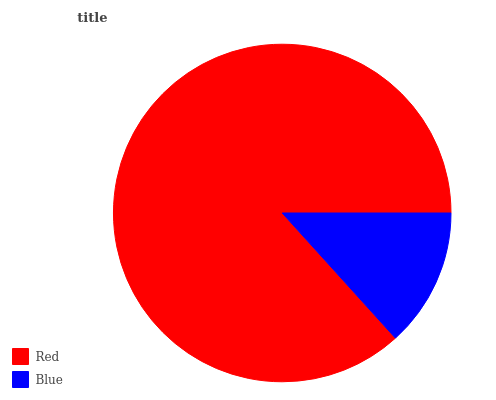Is Blue the minimum?
Answer yes or no. Yes. Is Red the maximum?
Answer yes or no. Yes. Is Blue the maximum?
Answer yes or no. No. Is Red greater than Blue?
Answer yes or no. Yes. Is Blue less than Red?
Answer yes or no. Yes. Is Blue greater than Red?
Answer yes or no. No. Is Red less than Blue?
Answer yes or no. No. Is Red the high median?
Answer yes or no. Yes. Is Blue the low median?
Answer yes or no. Yes. Is Blue the high median?
Answer yes or no. No. Is Red the low median?
Answer yes or no. No. 